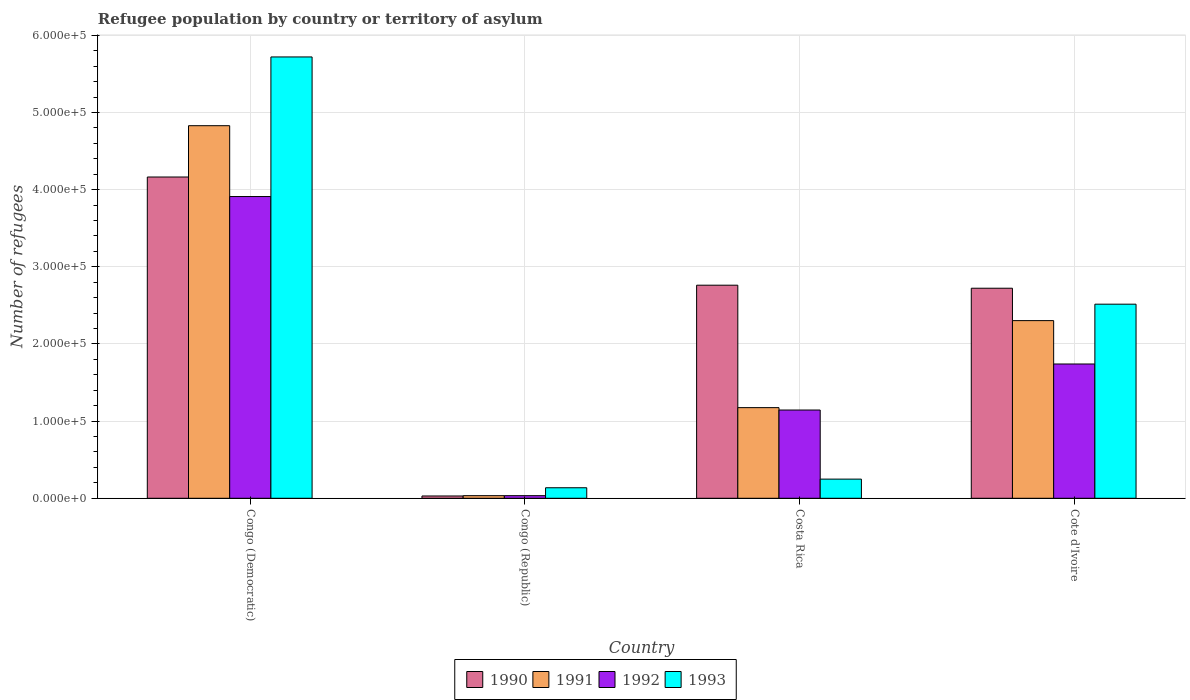How many different coloured bars are there?
Offer a very short reply. 4. Are the number of bars per tick equal to the number of legend labels?
Your response must be concise. Yes. How many bars are there on the 2nd tick from the right?
Provide a short and direct response. 4. What is the label of the 2nd group of bars from the left?
Your answer should be compact. Congo (Republic). In how many cases, is the number of bars for a given country not equal to the number of legend labels?
Give a very brief answer. 0. What is the number of refugees in 1992 in Congo (Republic)?
Make the answer very short. 3385. Across all countries, what is the maximum number of refugees in 1992?
Your answer should be very brief. 3.91e+05. Across all countries, what is the minimum number of refugees in 1992?
Your response must be concise. 3385. In which country was the number of refugees in 1991 maximum?
Your response must be concise. Congo (Democratic). In which country was the number of refugees in 1991 minimum?
Your answer should be compact. Congo (Republic). What is the total number of refugees in 1993 in the graph?
Provide a short and direct response. 8.62e+05. What is the difference between the number of refugees in 1993 in Congo (Republic) and that in Costa Rica?
Give a very brief answer. -1.12e+04. What is the difference between the number of refugees in 1992 in Costa Rica and the number of refugees in 1991 in Cote d'Ivoire?
Offer a terse response. -1.16e+05. What is the average number of refugees in 1992 per country?
Offer a terse response. 1.71e+05. What is the difference between the number of refugees of/in 1993 and number of refugees of/in 1992 in Congo (Republic)?
Provide a succinct answer. 1.03e+04. What is the ratio of the number of refugees in 1991 in Congo (Democratic) to that in Costa Rica?
Offer a terse response. 4.11. Is the number of refugees in 1990 in Congo (Democratic) less than that in Costa Rica?
Make the answer very short. No. Is the difference between the number of refugees in 1993 in Congo (Democratic) and Costa Rica greater than the difference between the number of refugees in 1992 in Congo (Democratic) and Costa Rica?
Ensure brevity in your answer.  Yes. What is the difference between the highest and the second highest number of refugees in 1992?
Your answer should be compact. -5.97e+04. What is the difference between the highest and the lowest number of refugees in 1993?
Your answer should be compact. 5.58e+05. Is the sum of the number of refugees in 1991 in Congo (Democratic) and Costa Rica greater than the maximum number of refugees in 1993 across all countries?
Your answer should be very brief. Yes. Is it the case that in every country, the sum of the number of refugees in 1993 and number of refugees in 1991 is greater than the sum of number of refugees in 1992 and number of refugees in 1990?
Your answer should be very brief. No. What does the 1st bar from the left in Cote d'Ivoire represents?
Make the answer very short. 1990. What does the 4th bar from the right in Cote d'Ivoire represents?
Keep it short and to the point. 1990. Is it the case that in every country, the sum of the number of refugees in 1993 and number of refugees in 1991 is greater than the number of refugees in 1992?
Ensure brevity in your answer.  Yes. How many bars are there?
Give a very brief answer. 16. Are all the bars in the graph horizontal?
Your answer should be very brief. No. Does the graph contain grids?
Ensure brevity in your answer.  Yes. How many legend labels are there?
Provide a succinct answer. 4. What is the title of the graph?
Provide a succinct answer. Refugee population by country or territory of asylum. Does "1964" appear as one of the legend labels in the graph?
Provide a succinct answer. No. What is the label or title of the X-axis?
Offer a very short reply. Country. What is the label or title of the Y-axis?
Your answer should be compact. Number of refugees. What is the Number of refugees in 1990 in Congo (Democratic)?
Your answer should be compact. 4.16e+05. What is the Number of refugees in 1991 in Congo (Democratic)?
Give a very brief answer. 4.83e+05. What is the Number of refugees in 1992 in Congo (Democratic)?
Keep it short and to the point. 3.91e+05. What is the Number of refugees of 1993 in Congo (Democratic)?
Offer a terse response. 5.72e+05. What is the Number of refugees of 1990 in Congo (Republic)?
Offer a very short reply. 2990. What is the Number of refugees in 1991 in Congo (Republic)?
Your answer should be very brief. 3395. What is the Number of refugees of 1992 in Congo (Republic)?
Give a very brief answer. 3385. What is the Number of refugees of 1993 in Congo (Republic)?
Offer a terse response. 1.36e+04. What is the Number of refugees of 1990 in Costa Rica?
Give a very brief answer. 2.76e+05. What is the Number of refugees of 1991 in Costa Rica?
Offer a terse response. 1.17e+05. What is the Number of refugees of 1992 in Costa Rica?
Offer a terse response. 1.14e+05. What is the Number of refugees of 1993 in Costa Rica?
Offer a very short reply. 2.48e+04. What is the Number of refugees of 1990 in Cote d'Ivoire?
Provide a succinct answer. 2.72e+05. What is the Number of refugees in 1991 in Cote d'Ivoire?
Your response must be concise. 2.30e+05. What is the Number of refugees of 1992 in Cote d'Ivoire?
Offer a terse response. 1.74e+05. What is the Number of refugees of 1993 in Cote d'Ivoire?
Your answer should be compact. 2.52e+05. Across all countries, what is the maximum Number of refugees in 1990?
Your answer should be very brief. 4.16e+05. Across all countries, what is the maximum Number of refugees of 1991?
Ensure brevity in your answer.  4.83e+05. Across all countries, what is the maximum Number of refugees in 1992?
Offer a very short reply. 3.91e+05. Across all countries, what is the maximum Number of refugees of 1993?
Provide a short and direct response. 5.72e+05. Across all countries, what is the minimum Number of refugees in 1990?
Provide a short and direct response. 2990. Across all countries, what is the minimum Number of refugees of 1991?
Your response must be concise. 3395. Across all countries, what is the minimum Number of refugees in 1992?
Your answer should be compact. 3385. Across all countries, what is the minimum Number of refugees of 1993?
Keep it short and to the point. 1.36e+04. What is the total Number of refugees of 1990 in the graph?
Provide a short and direct response. 9.68e+05. What is the total Number of refugees in 1991 in the graph?
Offer a terse response. 8.34e+05. What is the total Number of refugees in 1992 in the graph?
Ensure brevity in your answer.  6.83e+05. What is the total Number of refugees in 1993 in the graph?
Your answer should be very brief. 8.62e+05. What is the difference between the Number of refugees in 1990 in Congo (Democratic) and that in Congo (Republic)?
Make the answer very short. 4.13e+05. What is the difference between the Number of refugees of 1991 in Congo (Democratic) and that in Congo (Republic)?
Ensure brevity in your answer.  4.80e+05. What is the difference between the Number of refugees in 1992 in Congo (Democratic) and that in Congo (Republic)?
Your response must be concise. 3.88e+05. What is the difference between the Number of refugees of 1993 in Congo (Democratic) and that in Congo (Republic)?
Provide a short and direct response. 5.58e+05. What is the difference between the Number of refugees in 1990 in Congo (Democratic) and that in Costa Rica?
Offer a very short reply. 1.40e+05. What is the difference between the Number of refugees in 1991 in Congo (Democratic) and that in Costa Rica?
Provide a succinct answer. 3.65e+05. What is the difference between the Number of refugees in 1992 in Congo (Democratic) and that in Costa Rica?
Keep it short and to the point. 2.77e+05. What is the difference between the Number of refugees in 1993 in Congo (Democratic) and that in Costa Rica?
Provide a short and direct response. 5.47e+05. What is the difference between the Number of refugees of 1990 in Congo (Democratic) and that in Cote d'Ivoire?
Provide a succinct answer. 1.44e+05. What is the difference between the Number of refugees of 1991 in Congo (Democratic) and that in Cote d'Ivoire?
Give a very brief answer. 2.53e+05. What is the difference between the Number of refugees in 1992 in Congo (Democratic) and that in Cote d'Ivoire?
Offer a very short reply. 2.17e+05. What is the difference between the Number of refugees of 1993 in Congo (Democratic) and that in Cote d'Ivoire?
Your answer should be very brief. 3.20e+05. What is the difference between the Number of refugees in 1990 in Congo (Republic) and that in Costa Rica?
Make the answer very short. -2.73e+05. What is the difference between the Number of refugees in 1991 in Congo (Republic) and that in Costa Rica?
Offer a terse response. -1.14e+05. What is the difference between the Number of refugees of 1992 in Congo (Republic) and that in Costa Rica?
Keep it short and to the point. -1.11e+05. What is the difference between the Number of refugees in 1993 in Congo (Republic) and that in Costa Rica?
Offer a very short reply. -1.12e+04. What is the difference between the Number of refugees in 1990 in Congo (Republic) and that in Cote d'Ivoire?
Your answer should be very brief. -2.69e+05. What is the difference between the Number of refugees of 1991 in Congo (Republic) and that in Cote d'Ivoire?
Your answer should be compact. -2.27e+05. What is the difference between the Number of refugees in 1992 in Congo (Republic) and that in Cote d'Ivoire?
Offer a very short reply. -1.71e+05. What is the difference between the Number of refugees in 1993 in Congo (Republic) and that in Cote d'Ivoire?
Provide a succinct answer. -2.38e+05. What is the difference between the Number of refugees of 1990 in Costa Rica and that in Cote d'Ivoire?
Provide a short and direct response. 3929. What is the difference between the Number of refugees in 1991 in Costa Rica and that in Cote d'Ivoire?
Offer a terse response. -1.13e+05. What is the difference between the Number of refugees of 1992 in Costa Rica and that in Cote d'Ivoire?
Keep it short and to the point. -5.97e+04. What is the difference between the Number of refugees in 1993 in Costa Rica and that in Cote d'Ivoire?
Provide a succinct answer. -2.27e+05. What is the difference between the Number of refugees of 1990 in Congo (Democratic) and the Number of refugees of 1991 in Congo (Republic)?
Provide a succinct answer. 4.13e+05. What is the difference between the Number of refugees of 1990 in Congo (Democratic) and the Number of refugees of 1992 in Congo (Republic)?
Ensure brevity in your answer.  4.13e+05. What is the difference between the Number of refugees in 1990 in Congo (Democratic) and the Number of refugees in 1993 in Congo (Republic)?
Provide a short and direct response. 4.03e+05. What is the difference between the Number of refugees in 1991 in Congo (Democratic) and the Number of refugees in 1992 in Congo (Republic)?
Make the answer very short. 4.80e+05. What is the difference between the Number of refugees of 1991 in Congo (Democratic) and the Number of refugees of 1993 in Congo (Republic)?
Your response must be concise. 4.69e+05. What is the difference between the Number of refugees in 1992 in Congo (Democratic) and the Number of refugees in 1993 in Congo (Republic)?
Your answer should be very brief. 3.77e+05. What is the difference between the Number of refugees in 1990 in Congo (Democratic) and the Number of refugees in 1991 in Costa Rica?
Provide a short and direct response. 2.99e+05. What is the difference between the Number of refugees of 1990 in Congo (Democratic) and the Number of refugees of 1992 in Costa Rica?
Ensure brevity in your answer.  3.02e+05. What is the difference between the Number of refugees in 1990 in Congo (Democratic) and the Number of refugees in 1993 in Costa Rica?
Keep it short and to the point. 3.92e+05. What is the difference between the Number of refugees of 1991 in Congo (Democratic) and the Number of refugees of 1992 in Costa Rica?
Provide a succinct answer. 3.69e+05. What is the difference between the Number of refugees in 1991 in Congo (Democratic) and the Number of refugees in 1993 in Costa Rica?
Give a very brief answer. 4.58e+05. What is the difference between the Number of refugees of 1992 in Congo (Democratic) and the Number of refugees of 1993 in Costa Rica?
Offer a terse response. 3.66e+05. What is the difference between the Number of refugees in 1990 in Congo (Democratic) and the Number of refugees in 1991 in Cote d'Ivoire?
Make the answer very short. 1.86e+05. What is the difference between the Number of refugees in 1990 in Congo (Democratic) and the Number of refugees in 1992 in Cote d'Ivoire?
Offer a very short reply. 2.42e+05. What is the difference between the Number of refugees in 1990 in Congo (Democratic) and the Number of refugees in 1993 in Cote d'Ivoire?
Your answer should be very brief. 1.65e+05. What is the difference between the Number of refugees in 1991 in Congo (Democratic) and the Number of refugees in 1992 in Cote d'Ivoire?
Your answer should be very brief. 3.09e+05. What is the difference between the Number of refugees in 1991 in Congo (Democratic) and the Number of refugees in 1993 in Cote d'Ivoire?
Make the answer very short. 2.31e+05. What is the difference between the Number of refugees in 1992 in Congo (Democratic) and the Number of refugees in 1993 in Cote d'Ivoire?
Provide a short and direct response. 1.40e+05. What is the difference between the Number of refugees in 1990 in Congo (Republic) and the Number of refugees in 1991 in Costa Rica?
Provide a short and direct response. -1.15e+05. What is the difference between the Number of refugees in 1990 in Congo (Republic) and the Number of refugees in 1992 in Costa Rica?
Give a very brief answer. -1.11e+05. What is the difference between the Number of refugees in 1990 in Congo (Republic) and the Number of refugees in 1993 in Costa Rica?
Offer a very short reply. -2.18e+04. What is the difference between the Number of refugees in 1991 in Congo (Republic) and the Number of refugees in 1992 in Costa Rica?
Offer a very short reply. -1.11e+05. What is the difference between the Number of refugees of 1991 in Congo (Republic) and the Number of refugees of 1993 in Costa Rica?
Keep it short and to the point. -2.14e+04. What is the difference between the Number of refugees in 1992 in Congo (Republic) and the Number of refugees in 1993 in Costa Rica?
Keep it short and to the point. -2.14e+04. What is the difference between the Number of refugees of 1990 in Congo (Republic) and the Number of refugees of 1991 in Cote d'Ivoire?
Offer a terse response. -2.27e+05. What is the difference between the Number of refugees in 1990 in Congo (Republic) and the Number of refugees in 1992 in Cote d'Ivoire?
Your answer should be very brief. -1.71e+05. What is the difference between the Number of refugees of 1990 in Congo (Republic) and the Number of refugees of 1993 in Cote d'Ivoire?
Offer a very short reply. -2.49e+05. What is the difference between the Number of refugees in 1991 in Congo (Republic) and the Number of refugees in 1992 in Cote d'Ivoire?
Offer a terse response. -1.71e+05. What is the difference between the Number of refugees of 1991 in Congo (Republic) and the Number of refugees of 1993 in Cote d'Ivoire?
Your response must be concise. -2.48e+05. What is the difference between the Number of refugees in 1992 in Congo (Republic) and the Number of refugees in 1993 in Cote d'Ivoire?
Your answer should be compact. -2.48e+05. What is the difference between the Number of refugees of 1990 in Costa Rica and the Number of refugees of 1991 in Cote d'Ivoire?
Your answer should be very brief. 4.59e+04. What is the difference between the Number of refugees in 1990 in Costa Rica and the Number of refugees in 1992 in Cote d'Ivoire?
Your response must be concise. 1.02e+05. What is the difference between the Number of refugees in 1990 in Costa Rica and the Number of refugees in 1993 in Cote d'Ivoire?
Offer a very short reply. 2.46e+04. What is the difference between the Number of refugees of 1991 in Costa Rica and the Number of refugees of 1992 in Cote d'Ivoire?
Provide a short and direct response. -5.66e+04. What is the difference between the Number of refugees of 1991 in Costa Rica and the Number of refugees of 1993 in Cote d'Ivoire?
Give a very brief answer. -1.34e+05. What is the difference between the Number of refugees of 1992 in Costa Rica and the Number of refugees of 1993 in Cote d'Ivoire?
Keep it short and to the point. -1.37e+05. What is the average Number of refugees of 1990 per country?
Offer a terse response. 2.42e+05. What is the average Number of refugees in 1991 per country?
Offer a very short reply. 2.09e+05. What is the average Number of refugees of 1992 per country?
Give a very brief answer. 1.71e+05. What is the average Number of refugees of 1993 per country?
Offer a very short reply. 2.16e+05. What is the difference between the Number of refugees in 1990 and Number of refugees in 1991 in Congo (Democratic)?
Make the answer very short. -6.65e+04. What is the difference between the Number of refugees of 1990 and Number of refugees of 1992 in Congo (Democratic)?
Your answer should be compact. 2.53e+04. What is the difference between the Number of refugees of 1990 and Number of refugees of 1993 in Congo (Democratic)?
Your response must be concise. -1.56e+05. What is the difference between the Number of refugees in 1991 and Number of refugees in 1992 in Congo (Democratic)?
Ensure brevity in your answer.  9.18e+04. What is the difference between the Number of refugees in 1991 and Number of refugees in 1993 in Congo (Democratic)?
Your answer should be very brief. -8.91e+04. What is the difference between the Number of refugees in 1992 and Number of refugees in 1993 in Congo (Democratic)?
Provide a short and direct response. -1.81e+05. What is the difference between the Number of refugees in 1990 and Number of refugees in 1991 in Congo (Republic)?
Provide a short and direct response. -405. What is the difference between the Number of refugees in 1990 and Number of refugees in 1992 in Congo (Republic)?
Make the answer very short. -395. What is the difference between the Number of refugees of 1990 and Number of refugees of 1993 in Congo (Republic)?
Your response must be concise. -1.07e+04. What is the difference between the Number of refugees of 1991 and Number of refugees of 1992 in Congo (Republic)?
Give a very brief answer. 10. What is the difference between the Number of refugees of 1991 and Number of refugees of 1993 in Congo (Republic)?
Ensure brevity in your answer.  -1.03e+04. What is the difference between the Number of refugees of 1992 and Number of refugees of 1993 in Congo (Republic)?
Offer a terse response. -1.03e+04. What is the difference between the Number of refugees of 1990 and Number of refugees of 1991 in Costa Rica?
Make the answer very short. 1.59e+05. What is the difference between the Number of refugees in 1990 and Number of refugees in 1992 in Costa Rica?
Provide a succinct answer. 1.62e+05. What is the difference between the Number of refugees in 1990 and Number of refugees in 1993 in Costa Rica?
Provide a succinct answer. 2.51e+05. What is the difference between the Number of refugees in 1991 and Number of refugees in 1992 in Costa Rica?
Ensure brevity in your answer.  3100. What is the difference between the Number of refugees of 1991 and Number of refugees of 1993 in Costa Rica?
Make the answer very short. 9.27e+04. What is the difference between the Number of refugees of 1992 and Number of refugees of 1993 in Costa Rica?
Your response must be concise. 8.96e+04. What is the difference between the Number of refugees in 1990 and Number of refugees in 1991 in Cote d'Ivoire?
Provide a short and direct response. 4.20e+04. What is the difference between the Number of refugees of 1990 and Number of refugees of 1992 in Cote d'Ivoire?
Make the answer very short. 9.82e+04. What is the difference between the Number of refugees of 1990 and Number of refugees of 1993 in Cote d'Ivoire?
Your answer should be compact. 2.07e+04. What is the difference between the Number of refugees in 1991 and Number of refugees in 1992 in Cote d'Ivoire?
Provide a short and direct response. 5.62e+04. What is the difference between the Number of refugees in 1991 and Number of refugees in 1993 in Cote d'Ivoire?
Offer a terse response. -2.13e+04. What is the difference between the Number of refugees of 1992 and Number of refugees of 1993 in Cote d'Ivoire?
Give a very brief answer. -7.75e+04. What is the ratio of the Number of refugees of 1990 in Congo (Democratic) to that in Congo (Republic)?
Your answer should be very brief. 139.28. What is the ratio of the Number of refugees in 1991 in Congo (Democratic) to that in Congo (Republic)?
Make the answer very short. 142.26. What is the ratio of the Number of refugees of 1992 in Congo (Democratic) to that in Congo (Republic)?
Provide a succinct answer. 115.55. What is the ratio of the Number of refugees of 1993 in Congo (Democratic) to that in Congo (Republic)?
Ensure brevity in your answer.  41.92. What is the ratio of the Number of refugees of 1990 in Congo (Democratic) to that in Costa Rica?
Offer a terse response. 1.51. What is the ratio of the Number of refugees in 1991 in Congo (Democratic) to that in Costa Rica?
Provide a succinct answer. 4.11. What is the ratio of the Number of refugees of 1992 in Congo (Democratic) to that in Costa Rica?
Your answer should be compact. 3.42. What is the ratio of the Number of refugees of 1993 in Congo (Democratic) to that in Costa Rica?
Ensure brevity in your answer.  23.04. What is the ratio of the Number of refugees of 1990 in Congo (Democratic) to that in Cote d'Ivoire?
Provide a succinct answer. 1.53. What is the ratio of the Number of refugees of 1991 in Congo (Democratic) to that in Cote d'Ivoire?
Give a very brief answer. 2.1. What is the ratio of the Number of refugees of 1992 in Congo (Democratic) to that in Cote d'Ivoire?
Give a very brief answer. 2.25. What is the ratio of the Number of refugees of 1993 in Congo (Democratic) to that in Cote d'Ivoire?
Offer a terse response. 2.27. What is the ratio of the Number of refugees of 1990 in Congo (Republic) to that in Costa Rica?
Your answer should be very brief. 0.01. What is the ratio of the Number of refugees in 1991 in Congo (Republic) to that in Costa Rica?
Provide a short and direct response. 0.03. What is the ratio of the Number of refugees in 1992 in Congo (Republic) to that in Costa Rica?
Make the answer very short. 0.03. What is the ratio of the Number of refugees of 1993 in Congo (Republic) to that in Costa Rica?
Provide a succinct answer. 0.55. What is the ratio of the Number of refugees of 1990 in Congo (Republic) to that in Cote d'Ivoire?
Your response must be concise. 0.01. What is the ratio of the Number of refugees of 1991 in Congo (Republic) to that in Cote d'Ivoire?
Ensure brevity in your answer.  0.01. What is the ratio of the Number of refugees in 1992 in Congo (Republic) to that in Cote d'Ivoire?
Offer a terse response. 0.02. What is the ratio of the Number of refugees in 1993 in Congo (Republic) to that in Cote d'Ivoire?
Ensure brevity in your answer.  0.05. What is the ratio of the Number of refugees in 1990 in Costa Rica to that in Cote d'Ivoire?
Make the answer very short. 1.01. What is the ratio of the Number of refugees of 1991 in Costa Rica to that in Cote d'Ivoire?
Give a very brief answer. 0.51. What is the ratio of the Number of refugees in 1992 in Costa Rica to that in Cote d'Ivoire?
Offer a very short reply. 0.66. What is the ratio of the Number of refugees of 1993 in Costa Rica to that in Cote d'Ivoire?
Give a very brief answer. 0.1. What is the difference between the highest and the second highest Number of refugees of 1990?
Make the answer very short. 1.40e+05. What is the difference between the highest and the second highest Number of refugees in 1991?
Ensure brevity in your answer.  2.53e+05. What is the difference between the highest and the second highest Number of refugees in 1992?
Your response must be concise. 2.17e+05. What is the difference between the highest and the second highest Number of refugees of 1993?
Provide a short and direct response. 3.20e+05. What is the difference between the highest and the lowest Number of refugees of 1990?
Your answer should be compact. 4.13e+05. What is the difference between the highest and the lowest Number of refugees in 1991?
Your answer should be compact. 4.80e+05. What is the difference between the highest and the lowest Number of refugees of 1992?
Your answer should be very brief. 3.88e+05. What is the difference between the highest and the lowest Number of refugees of 1993?
Offer a terse response. 5.58e+05. 